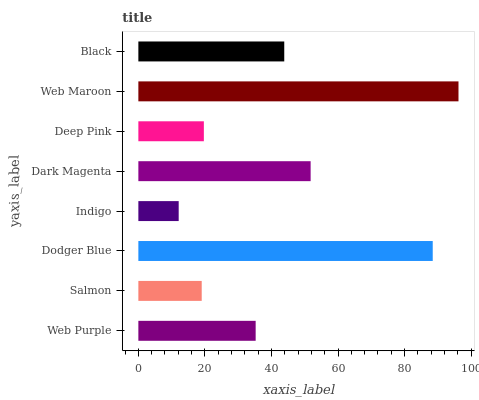Is Indigo the minimum?
Answer yes or no. Yes. Is Web Maroon the maximum?
Answer yes or no. Yes. Is Salmon the minimum?
Answer yes or no. No. Is Salmon the maximum?
Answer yes or no. No. Is Web Purple greater than Salmon?
Answer yes or no. Yes. Is Salmon less than Web Purple?
Answer yes or no. Yes. Is Salmon greater than Web Purple?
Answer yes or no. No. Is Web Purple less than Salmon?
Answer yes or no. No. Is Black the high median?
Answer yes or no. Yes. Is Web Purple the low median?
Answer yes or no. Yes. Is Dark Magenta the high median?
Answer yes or no. No. Is Deep Pink the low median?
Answer yes or no. No. 